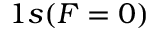<formula> <loc_0><loc_0><loc_500><loc_500>1 s ( F = 0 )</formula> 